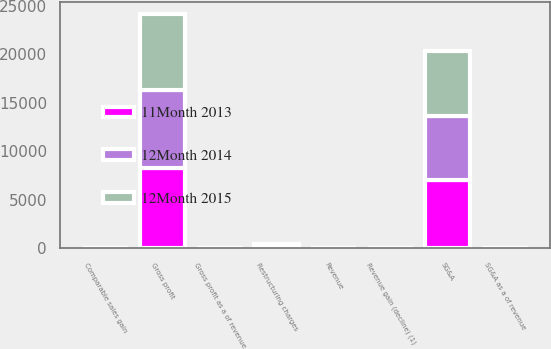Convert chart. <chart><loc_0><loc_0><loc_500><loc_500><stacked_bar_chart><ecel><fcel>Revenue<fcel>Revenue gain (decline) (1)<fcel>Comparable sales gain<fcel>Gross profit<fcel>Gross profit as a of revenue<fcel>SG&A<fcel>SG&A as a of revenue<fcel>Restructuring charges<nl><fcel>12Month 2014<fcel>22.4<fcel>0.6<fcel>1<fcel>8080<fcel>22.4<fcel>6639<fcel>18.4<fcel>4<nl><fcel>11Month 2013<fcel>22.4<fcel>7.9<fcel>0.4<fcel>8274<fcel>23.1<fcel>7006<fcel>19.6<fcel>123<nl><fcel>12Month 2015<fcel>22.4<fcel>2.6<fcel>1.7<fcel>7789<fcel>23.4<fcel>6728<fcel>20.3<fcel>327<nl></chart> 